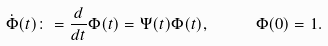Convert formula to latex. <formula><loc_0><loc_0><loc_500><loc_500>\dot { \Phi } ( t ) \colon = \frac { d } { d t } \Phi ( t ) = \Psi ( t ) \Phi ( t ) , \quad \ \Phi ( 0 ) = 1 .</formula> 